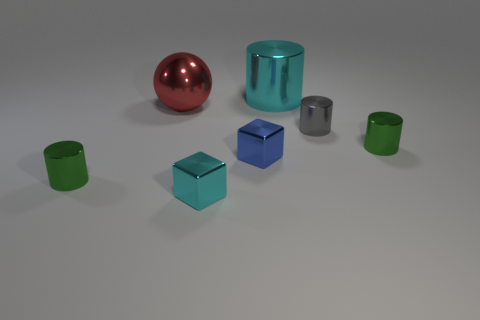Subtract 1 cylinders. How many cylinders are left? 3 Add 2 red things. How many objects exist? 9 Subtract all cubes. How many objects are left? 5 Subtract 0 red blocks. How many objects are left? 7 Subtract all gray metallic cylinders. Subtract all large shiny balls. How many objects are left? 5 Add 5 small green objects. How many small green objects are left? 7 Add 6 large cyan shiny objects. How many large cyan shiny objects exist? 7 